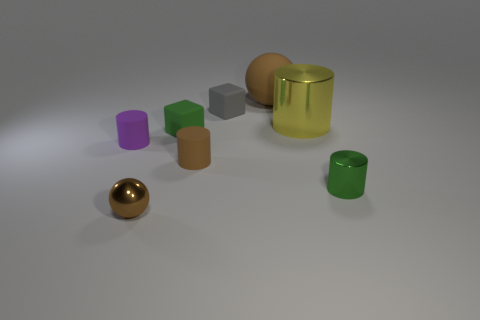Subtract all yellow metal cylinders. How many cylinders are left? 3 Add 1 large metallic things. How many objects exist? 9 Subtract all green cylinders. How many cylinders are left? 3 Subtract 1 cylinders. How many cylinders are left? 3 Add 1 big yellow metallic things. How many big yellow metallic things exist? 2 Subtract 0 purple spheres. How many objects are left? 8 Subtract all blocks. How many objects are left? 6 Subtract all gray cylinders. Subtract all blue spheres. How many cylinders are left? 4 Subtract all tiny matte cubes. Subtract all brown objects. How many objects are left? 3 Add 7 small green metallic cylinders. How many small green metallic cylinders are left? 8 